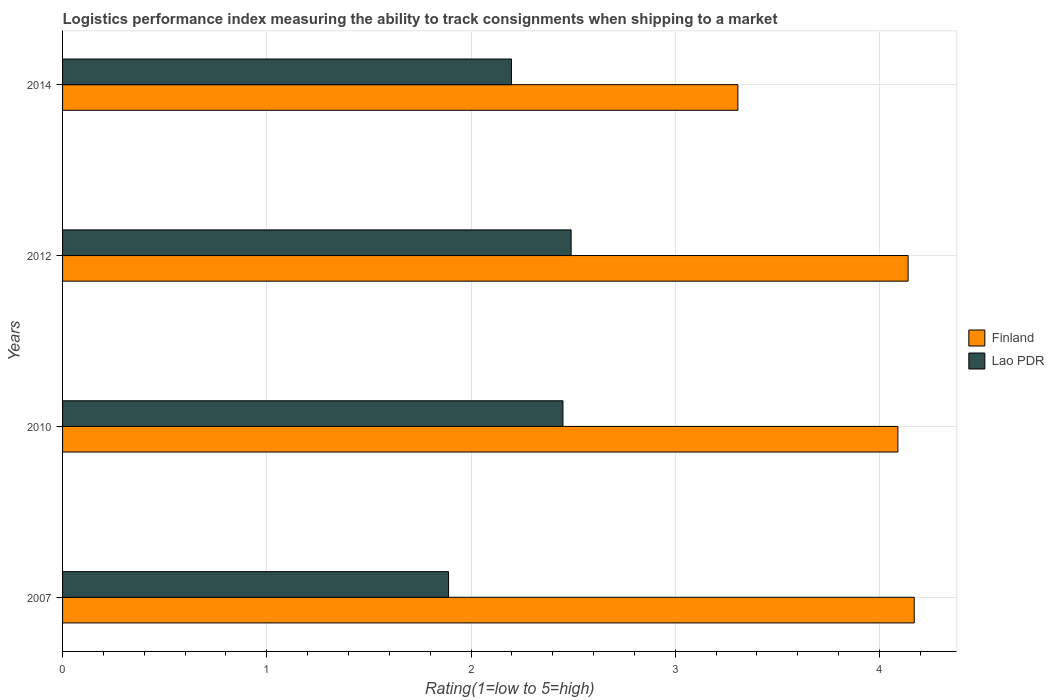How many different coloured bars are there?
Give a very brief answer. 2. How many groups of bars are there?
Keep it short and to the point. 4. Are the number of bars on each tick of the Y-axis equal?
Your answer should be compact. Yes. How many bars are there on the 4th tick from the top?
Provide a succinct answer. 2. How many bars are there on the 1st tick from the bottom?
Your answer should be very brief. 2. What is the label of the 1st group of bars from the top?
Offer a terse response. 2014. In how many cases, is the number of bars for a given year not equal to the number of legend labels?
Ensure brevity in your answer.  0. What is the Logistic performance index in Finland in 2014?
Ensure brevity in your answer.  3.31. Across all years, what is the maximum Logistic performance index in Lao PDR?
Your answer should be compact. 2.49. Across all years, what is the minimum Logistic performance index in Finland?
Provide a short and direct response. 3.31. In which year was the Logistic performance index in Lao PDR maximum?
Make the answer very short. 2012. What is the total Logistic performance index in Lao PDR in the graph?
Offer a terse response. 9.03. What is the difference between the Logistic performance index in Finland in 2007 and that in 2010?
Keep it short and to the point. 0.08. What is the difference between the Logistic performance index in Lao PDR in 2010 and the Logistic performance index in Finland in 2012?
Keep it short and to the point. -1.69. What is the average Logistic performance index in Finland per year?
Offer a very short reply. 3.93. In the year 2010, what is the difference between the Logistic performance index in Finland and Logistic performance index in Lao PDR?
Offer a very short reply. 1.64. What is the ratio of the Logistic performance index in Finland in 2007 to that in 2010?
Provide a short and direct response. 1.02. Is the Logistic performance index in Lao PDR in 2010 less than that in 2014?
Give a very brief answer. No. What is the difference between the highest and the second highest Logistic performance index in Finland?
Keep it short and to the point. 0.03. What is the difference between the highest and the lowest Logistic performance index in Lao PDR?
Provide a short and direct response. 0.6. In how many years, is the Logistic performance index in Lao PDR greater than the average Logistic performance index in Lao PDR taken over all years?
Offer a terse response. 2. What does the 1st bar from the top in 2010 represents?
Your answer should be compact. Lao PDR. Are all the bars in the graph horizontal?
Provide a short and direct response. Yes. What is the difference between two consecutive major ticks on the X-axis?
Provide a short and direct response. 1. Are the values on the major ticks of X-axis written in scientific E-notation?
Keep it short and to the point. No. Does the graph contain grids?
Keep it short and to the point. Yes. Where does the legend appear in the graph?
Provide a short and direct response. Center right. How are the legend labels stacked?
Your answer should be compact. Vertical. What is the title of the graph?
Give a very brief answer. Logistics performance index measuring the ability to track consignments when shipping to a market. Does "Belize" appear as one of the legend labels in the graph?
Provide a short and direct response. No. What is the label or title of the X-axis?
Provide a succinct answer. Rating(1=low to 5=high). What is the label or title of the Y-axis?
Your response must be concise. Years. What is the Rating(1=low to 5=high) of Finland in 2007?
Offer a very short reply. 4.17. What is the Rating(1=low to 5=high) in Lao PDR in 2007?
Offer a very short reply. 1.89. What is the Rating(1=low to 5=high) of Finland in 2010?
Offer a very short reply. 4.09. What is the Rating(1=low to 5=high) of Lao PDR in 2010?
Give a very brief answer. 2.45. What is the Rating(1=low to 5=high) of Finland in 2012?
Provide a short and direct response. 4.14. What is the Rating(1=low to 5=high) in Lao PDR in 2012?
Offer a terse response. 2.49. What is the Rating(1=low to 5=high) in Finland in 2014?
Your response must be concise. 3.31. What is the Rating(1=low to 5=high) in Lao PDR in 2014?
Provide a succinct answer. 2.2. Across all years, what is the maximum Rating(1=low to 5=high) in Finland?
Your answer should be compact. 4.17. Across all years, what is the maximum Rating(1=low to 5=high) of Lao PDR?
Your response must be concise. 2.49. Across all years, what is the minimum Rating(1=low to 5=high) of Finland?
Provide a succinct answer. 3.31. Across all years, what is the minimum Rating(1=low to 5=high) of Lao PDR?
Your answer should be very brief. 1.89. What is the total Rating(1=low to 5=high) in Finland in the graph?
Ensure brevity in your answer.  15.71. What is the total Rating(1=low to 5=high) of Lao PDR in the graph?
Give a very brief answer. 9.03. What is the difference between the Rating(1=low to 5=high) of Lao PDR in 2007 and that in 2010?
Make the answer very short. -0.56. What is the difference between the Rating(1=low to 5=high) of Lao PDR in 2007 and that in 2012?
Your response must be concise. -0.6. What is the difference between the Rating(1=low to 5=high) in Finland in 2007 and that in 2014?
Give a very brief answer. 0.86. What is the difference between the Rating(1=low to 5=high) of Lao PDR in 2007 and that in 2014?
Your answer should be very brief. -0.31. What is the difference between the Rating(1=low to 5=high) in Lao PDR in 2010 and that in 2012?
Give a very brief answer. -0.04. What is the difference between the Rating(1=low to 5=high) in Finland in 2010 and that in 2014?
Your response must be concise. 0.78. What is the difference between the Rating(1=low to 5=high) of Lao PDR in 2010 and that in 2014?
Offer a terse response. 0.25. What is the difference between the Rating(1=low to 5=high) of Finland in 2012 and that in 2014?
Ensure brevity in your answer.  0.83. What is the difference between the Rating(1=low to 5=high) in Lao PDR in 2012 and that in 2014?
Provide a succinct answer. 0.29. What is the difference between the Rating(1=low to 5=high) in Finland in 2007 and the Rating(1=low to 5=high) in Lao PDR in 2010?
Your answer should be compact. 1.72. What is the difference between the Rating(1=low to 5=high) of Finland in 2007 and the Rating(1=low to 5=high) of Lao PDR in 2012?
Your answer should be very brief. 1.68. What is the difference between the Rating(1=low to 5=high) in Finland in 2007 and the Rating(1=low to 5=high) in Lao PDR in 2014?
Offer a very short reply. 1.97. What is the difference between the Rating(1=low to 5=high) in Finland in 2010 and the Rating(1=low to 5=high) in Lao PDR in 2014?
Make the answer very short. 1.89. What is the difference between the Rating(1=low to 5=high) of Finland in 2012 and the Rating(1=low to 5=high) of Lao PDR in 2014?
Keep it short and to the point. 1.94. What is the average Rating(1=low to 5=high) in Finland per year?
Provide a succinct answer. 3.93. What is the average Rating(1=low to 5=high) in Lao PDR per year?
Provide a short and direct response. 2.26. In the year 2007, what is the difference between the Rating(1=low to 5=high) of Finland and Rating(1=low to 5=high) of Lao PDR?
Make the answer very short. 2.28. In the year 2010, what is the difference between the Rating(1=low to 5=high) of Finland and Rating(1=low to 5=high) of Lao PDR?
Offer a terse response. 1.64. In the year 2012, what is the difference between the Rating(1=low to 5=high) of Finland and Rating(1=low to 5=high) of Lao PDR?
Make the answer very short. 1.65. In the year 2014, what is the difference between the Rating(1=low to 5=high) of Finland and Rating(1=low to 5=high) of Lao PDR?
Your answer should be very brief. 1.11. What is the ratio of the Rating(1=low to 5=high) in Finland in 2007 to that in 2010?
Keep it short and to the point. 1.02. What is the ratio of the Rating(1=low to 5=high) in Lao PDR in 2007 to that in 2010?
Keep it short and to the point. 0.77. What is the ratio of the Rating(1=low to 5=high) of Finland in 2007 to that in 2012?
Ensure brevity in your answer.  1.01. What is the ratio of the Rating(1=low to 5=high) of Lao PDR in 2007 to that in 2012?
Ensure brevity in your answer.  0.76. What is the ratio of the Rating(1=low to 5=high) in Finland in 2007 to that in 2014?
Give a very brief answer. 1.26. What is the ratio of the Rating(1=low to 5=high) of Lao PDR in 2007 to that in 2014?
Give a very brief answer. 0.86. What is the ratio of the Rating(1=low to 5=high) in Finland in 2010 to that in 2012?
Your response must be concise. 0.99. What is the ratio of the Rating(1=low to 5=high) of Lao PDR in 2010 to that in 2012?
Make the answer very short. 0.98. What is the ratio of the Rating(1=low to 5=high) in Finland in 2010 to that in 2014?
Provide a succinct answer. 1.24. What is the ratio of the Rating(1=low to 5=high) in Lao PDR in 2010 to that in 2014?
Your answer should be compact. 1.11. What is the ratio of the Rating(1=low to 5=high) of Finland in 2012 to that in 2014?
Offer a terse response. 1.25. What is the ratio of the Rating(1=low to 5=high) of Lao PDR in 2012 to that in 2014?
Keep it short and to the point. 1.13. What is the difference between the highest and the second highest Rating(1=low to 5=high) in Finland?
Offer a very short reply. 0.03. What is the difference between the highest and the second highest Rating(1=low to 5=high) of Lao PDR?
Ensure brevity in your answer.  0.04. What is the difference between the highest and the lowest Rating(1=low to 5=high) of Finland?
Ensure brevity in your answer.  0.86. What is the difference between the highest and the lowest Rating(1=low to 5=high) in Lao PDR?
Provide a short and direct response. 0.6. 